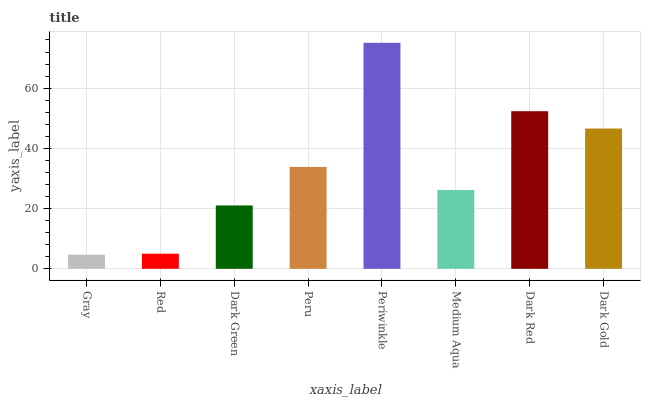Is Gray the minimum?
Answer yes or no. Yes. Is Periwinkle the maximum?
Answer yes or no. Yes. Is Red the minimum?
Answer yes or no. No. Is Red the maximum?
Answer yes or no. No. Is Red greater than Gray?
Answer yes or no. Yes. Is Gray less than Red?
Answer yes or no. Yes. Is Gray greater than Red?
Answer yes or no. No. Is Red less than Gray?
Answer yes or no. No. Is Peru the high median?
Answer yes or no. Yes. Is Medium Aqua the low median?
Answer yes or no. Yes. Is Dark Gold the high median?
Answer yes or no. No. Is Dark Green the low median?
Answer yes or no. No. 